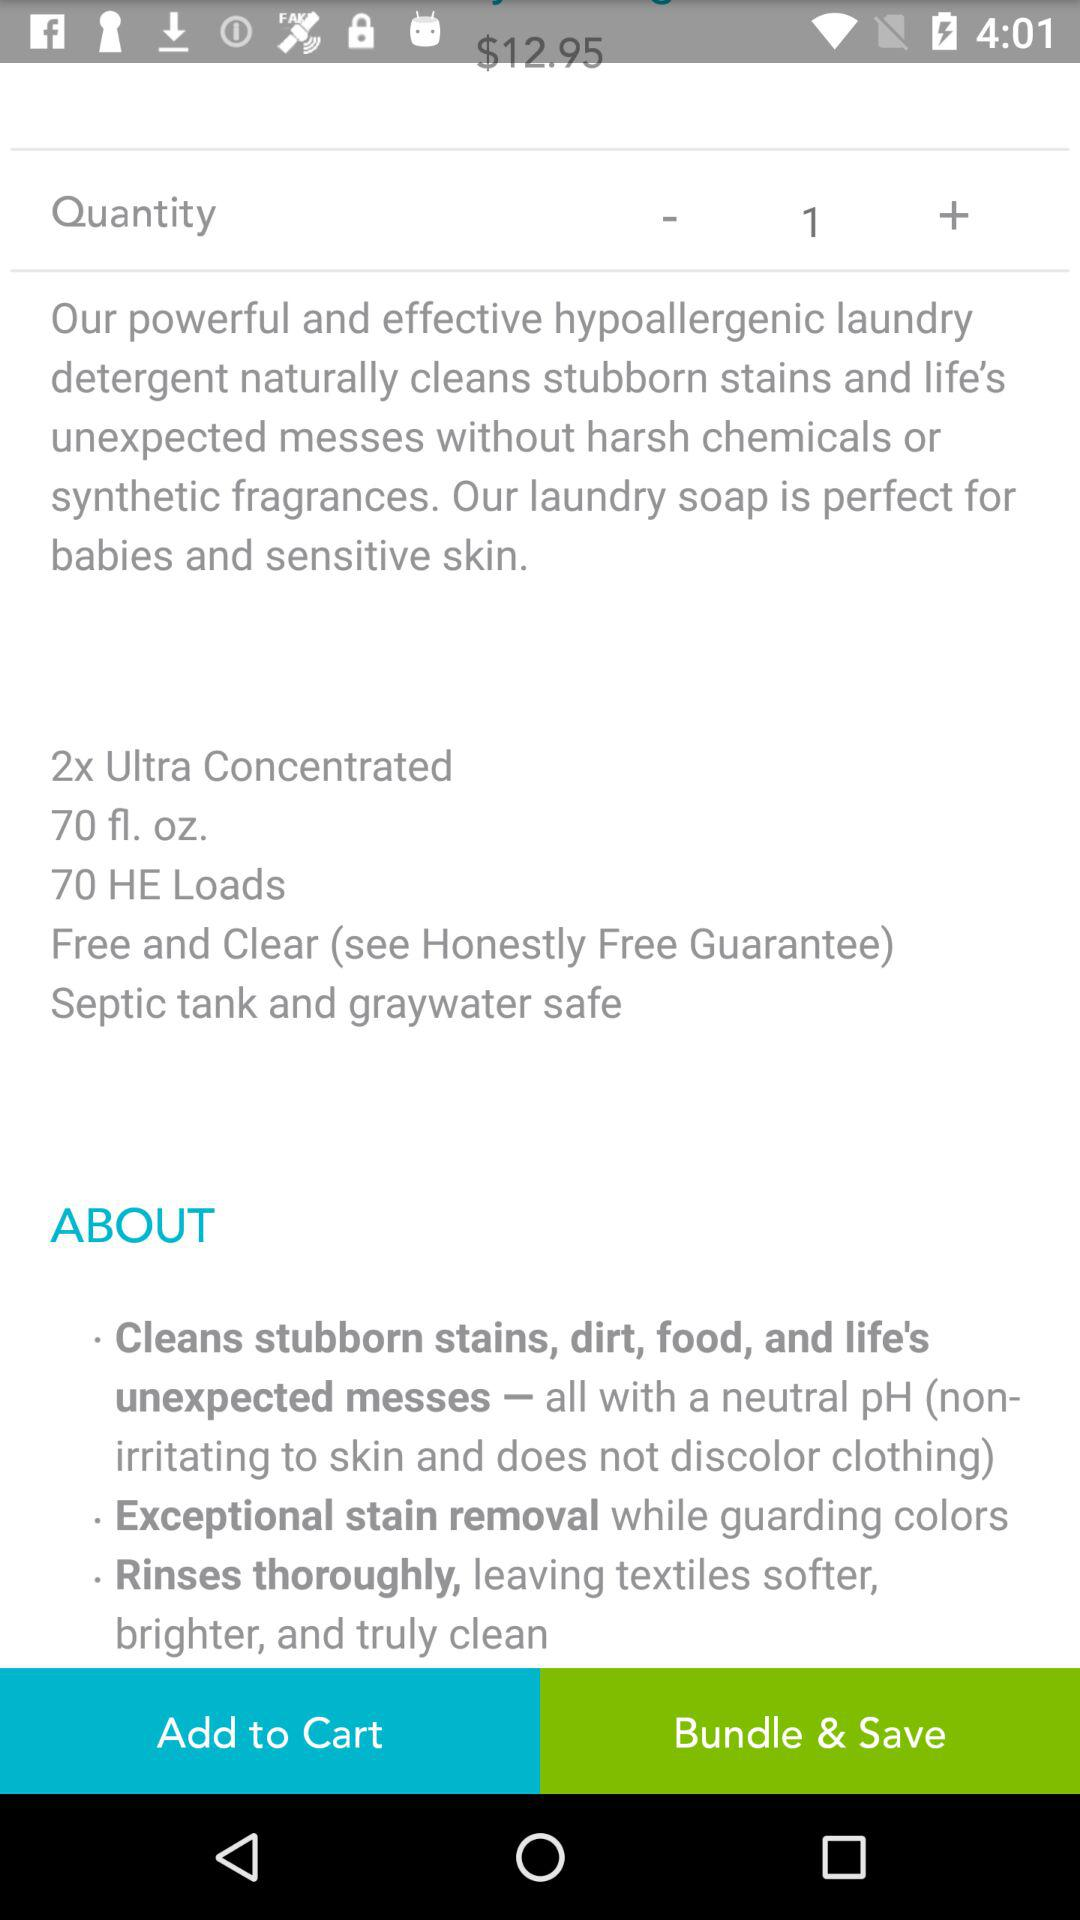How many HE loads does the laundry detergent come with?
Answer the question using a single word or phrase. 70 